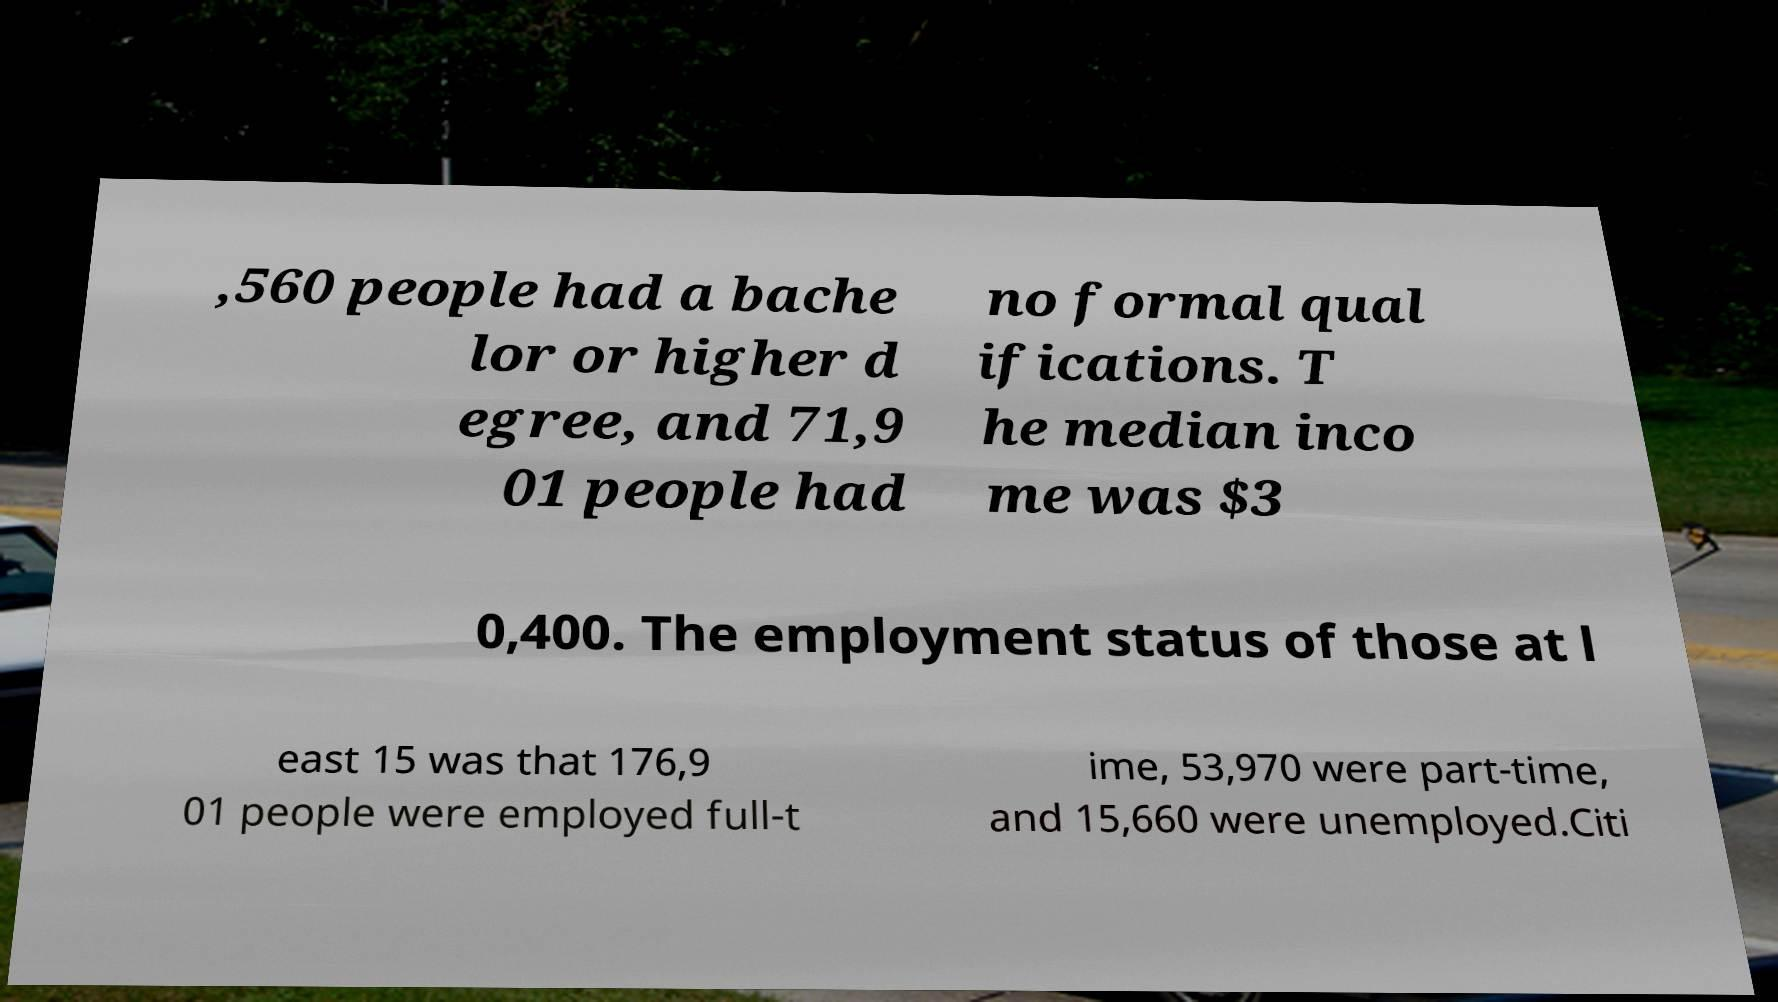I need the written content from this picture converted into text. Can you do that? ,560 people had a bache lor or higher d egree, and 71,9 01 people had no formal qual ifications. T he median inco me was $3 0,400. The employment status of those at l east 15 was that 176,9 01 people were employed full-t ime, 53,970 were part-time, and 15,660 were unemployed.Citi 